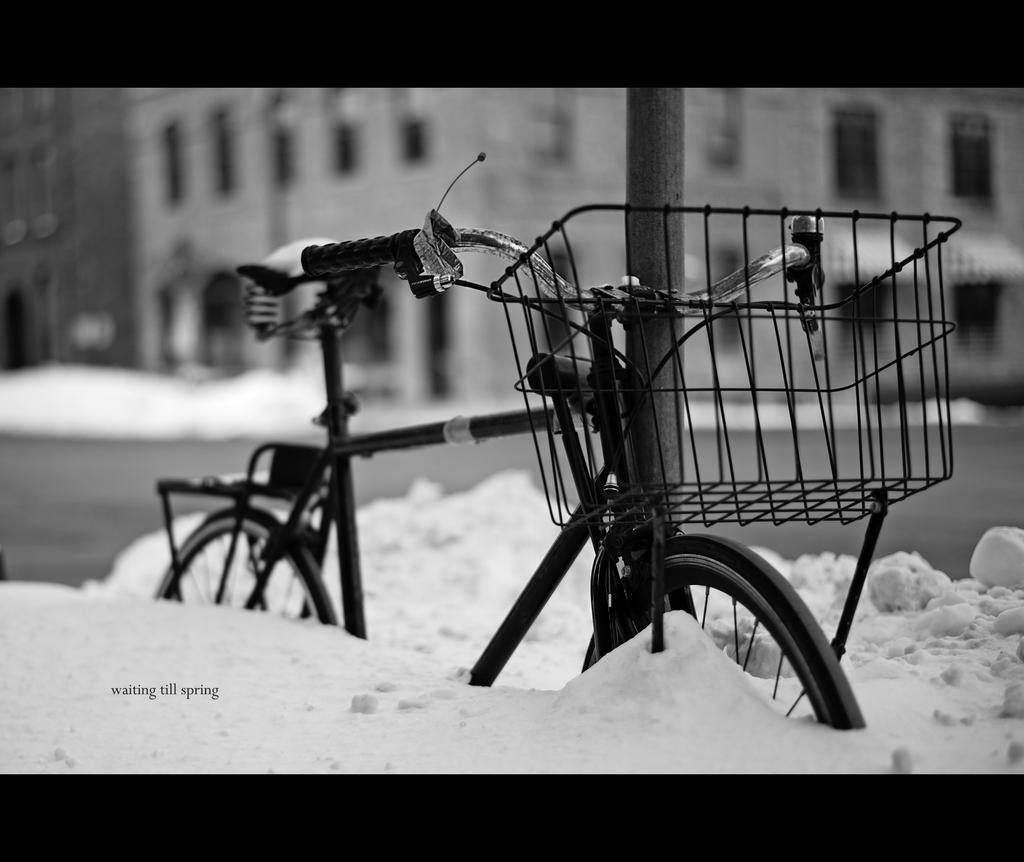Please provide a concise description of this image. This is a black and white image. In the center of the image we can see a bicycle and pole. In the background of the image we can see buildings, snow and road. 